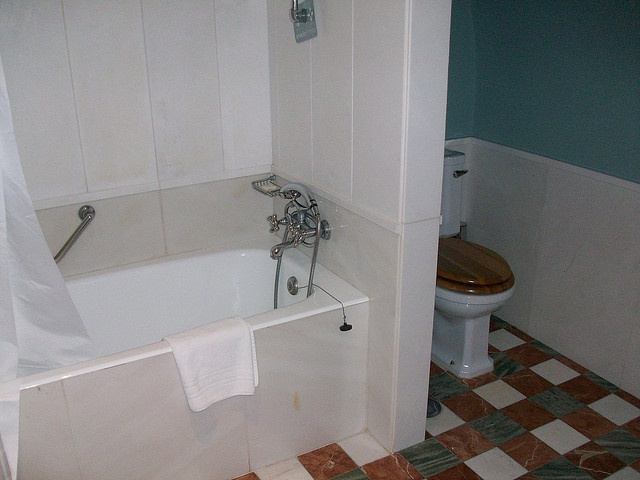Describe the objects in this image and their specific colors. I can see a toilet in gray, black, and maroon tones in this image. 